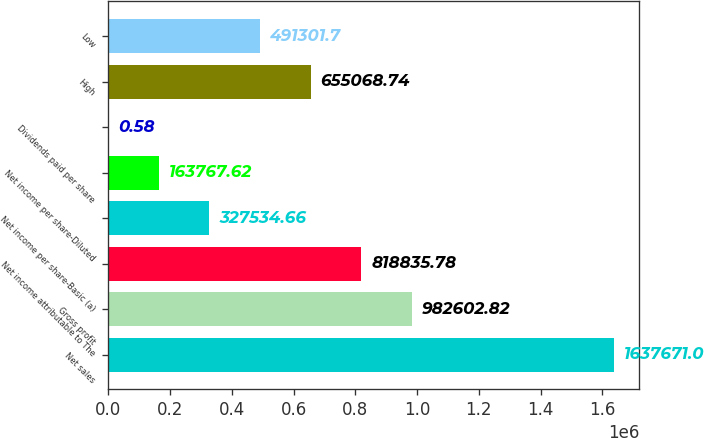<chart> <loc_0><loc_0><loc_500><loc_500><bar_chart><fcel>Net sales<fcel>Gross profit<fcel>Net income attributable to The<fcel>Net income per share-Basic (a)<fcel>Net income per share-Diluted<fcel>Dividends paid per share<fcel>High<fcel>Low<nl><fcel>1.63767e+06<fcel>982603<fcel>818836<fcel>327535<fcel>163768<fcel>0.58<fcel>655069<fcel>491302<nl></chart> 